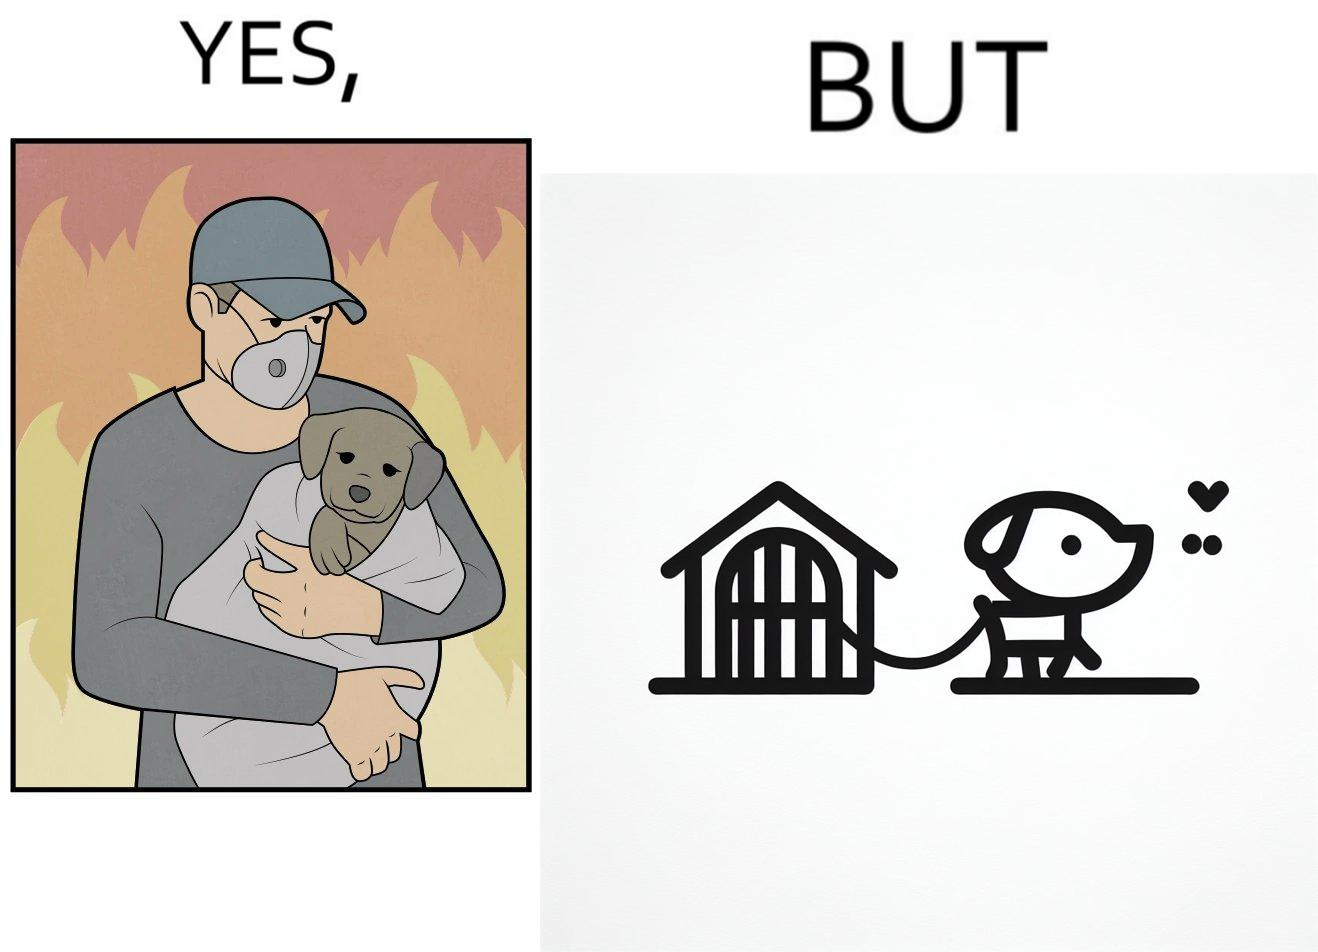Does this image contain satire or humor? Yes, this image is satirical. 